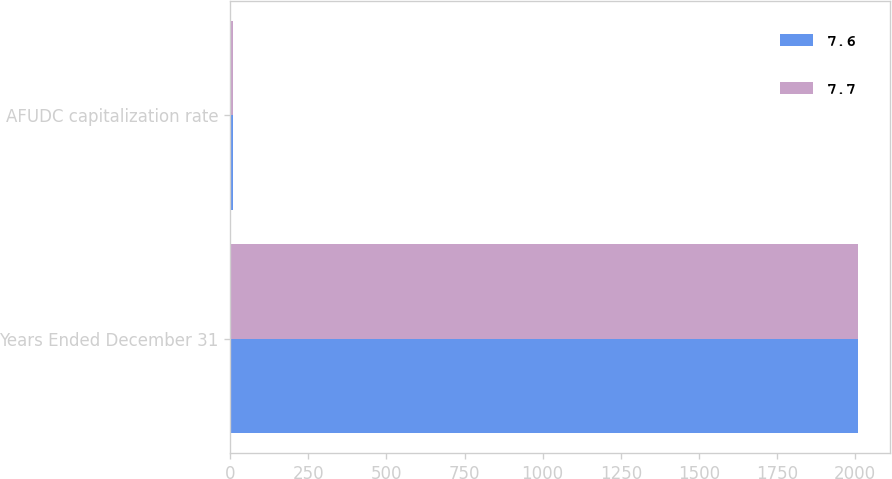<chart> <loc_0><loc_0><loc_500><loc_500><stacked_bar_chart><ecel><fcel>Years Ended December 31<fcel>AFUDC capitalization rate<nl><fcel>7.6<fcel>2010<fcel>7.6<nl><fcel>7.7<fcel>2008<fcel>7.7<nl></chart> 